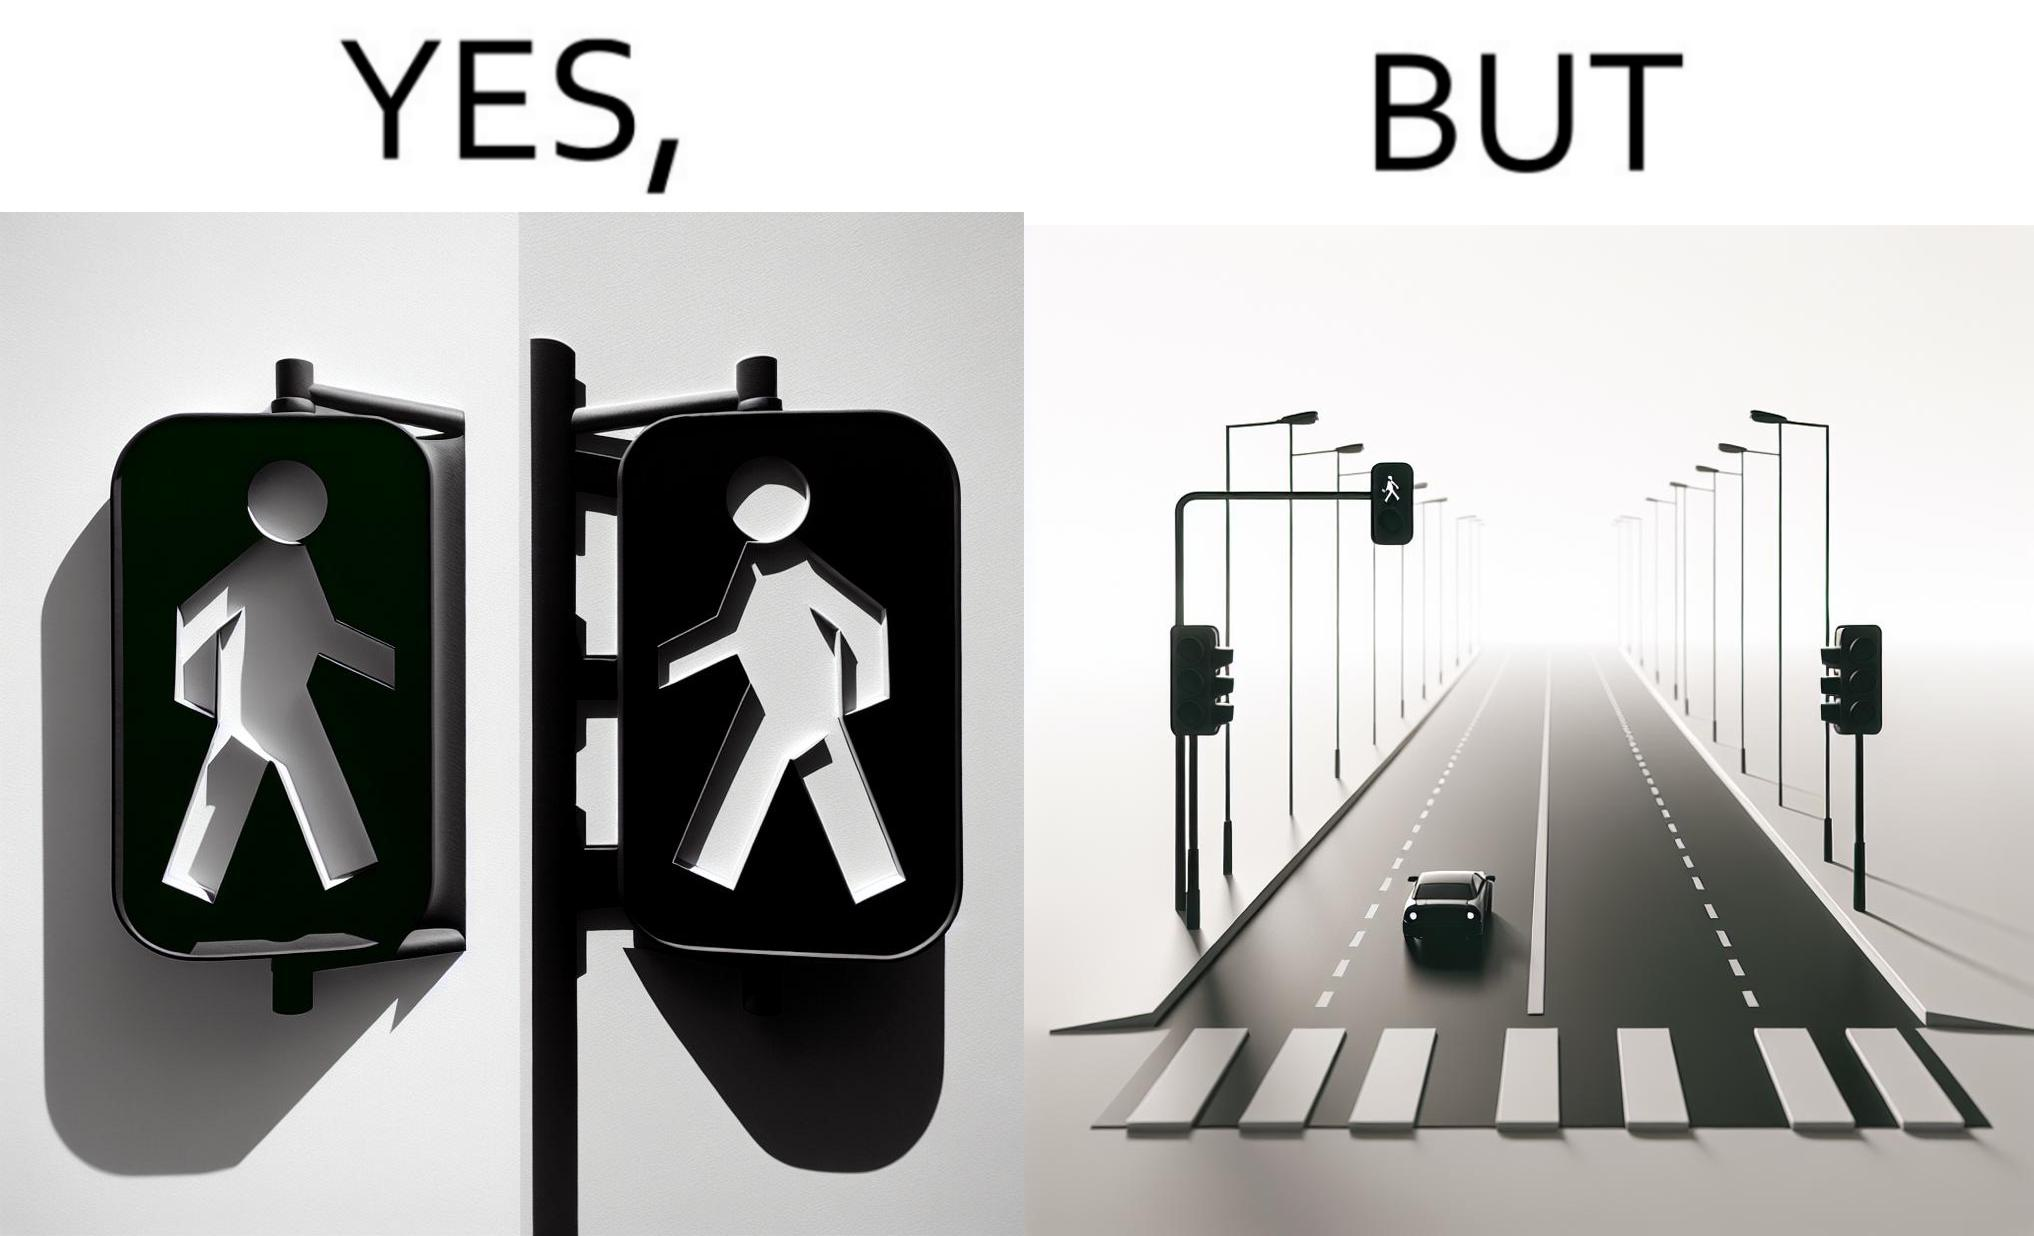Does this image contain satire or humor? Yes, this image is satirical. 